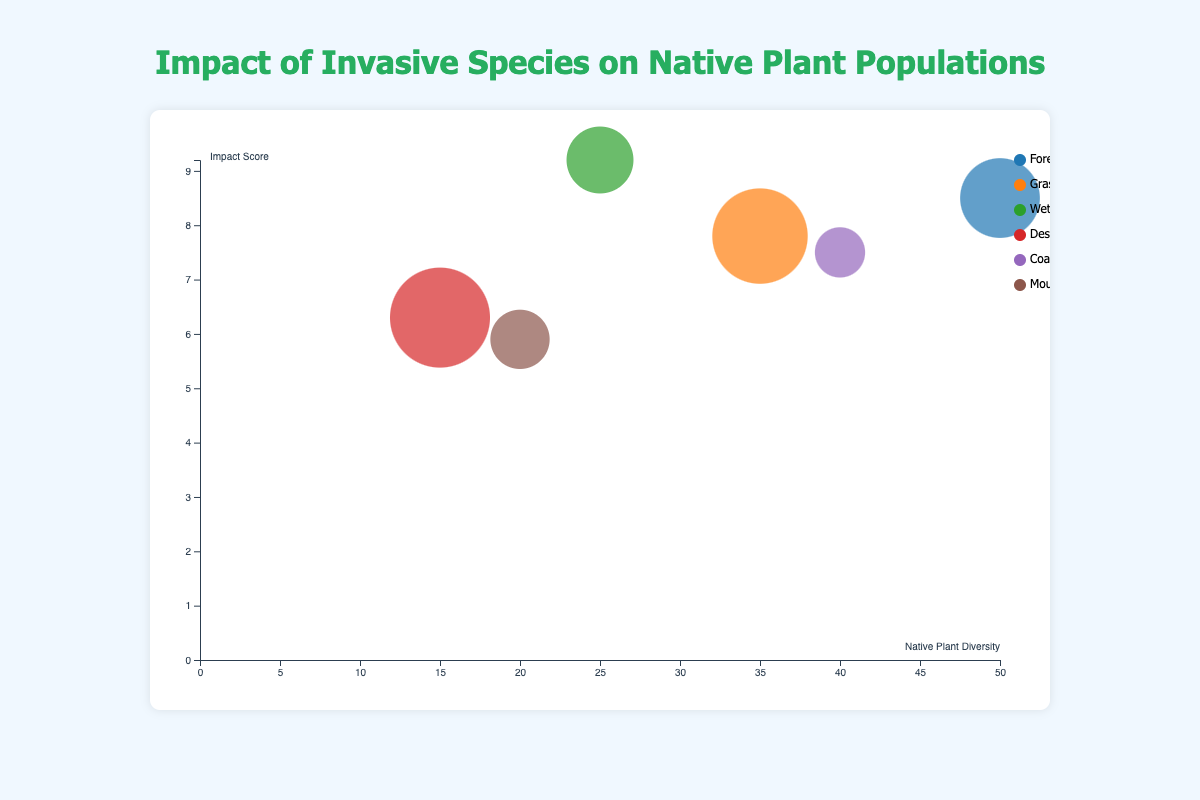What is the title of the figure? The title is usually displayed at the top of the chart and provides a summary of the data being presented. Here, the title is "Impact of Invasive Species on Native Plant Populations" as it's prominently shown above the chart.
Answer: Impact of Invasive Species on Native Plant Populations What are the axes labeled? The axes labels describe what each axis represents. In this figure, the x-axis is labeled "Native Plant Diversity" which ranges from 0 to 50, and the y-axis is labeled "Impact Score" which ranges from 0 to 10.
Answer: Native Plant Diversity, Impact Score Which habitat has the highest impact score? To find the habitat with the highest impact score, locate the topmost bubble along the y-axis (Impact Score). The "Wetlands" habitat with Purple Loosestrife has the highest impact score of 9.2.
Answer: Wetlands What is the relationship between habitat areas and native plant diversity? Examining the chart, habitats with larger affected areas tend to have lower native plant diversity. For example, Deserts with an area affected of 50 sq km have one of the lowest native plant diversities at 15. Conversely, Forests with an area of 30 sq km have a higher diversity of 50.
Answer: Inverse relationship Which habitat has the largest area affected by invasive species? The size of the bubbles represents the area affected. The largest bubble corresponds to "Deserts" affected by Buffelgrass, covering 50 sq km.
Answer: Deserts What is the impact score for forests and mountains? Locate the bubbles for "Forests" and "Mountains" and identify their positions along the y-axis. "Forests" have an impact score of 8.5, and "Mountains" have an impact score of 5.9.
Answer: 8.5, 5.9 Compare the native plant diversity between coastal regions and wetlands. Find the bubbles representing "Coastal Regions" and "Wetlands" and check their positions along the x-axis. "Coastal Regions" have a native plant diversity of 40, whereas "Wetlands" have a diversity of 25.
Answer: Coastal Regions have higher diversity How many habitats have a native plant diversity above 20? Count the number of bubbles positioned along the x-axis where the value of "Native Plant Diversity" is greater than 20. "Forests," "Grasslands," "Coastal Regions," and "Mountains" have diversity above 20, totaling 4 habitats.
Answer: 4 What is the total area affected by invasive species across all habitats? Sum the area affected values from all habitats (30 + 45 + 20 + 50 + 10 + 15). The total area is 170 sq km.
Answer: 170 sq km Which habitat shows the least impact score? Identify the bubble located lowest along the y-axis. The "Mountains" habitat affected by Yellow Toadflax shows the least impact score of 5.9.
Answer: Mountains 